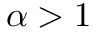<formula> <loc_0><loc_0><loc_500><loc_500>\alpha > 1</formula> 